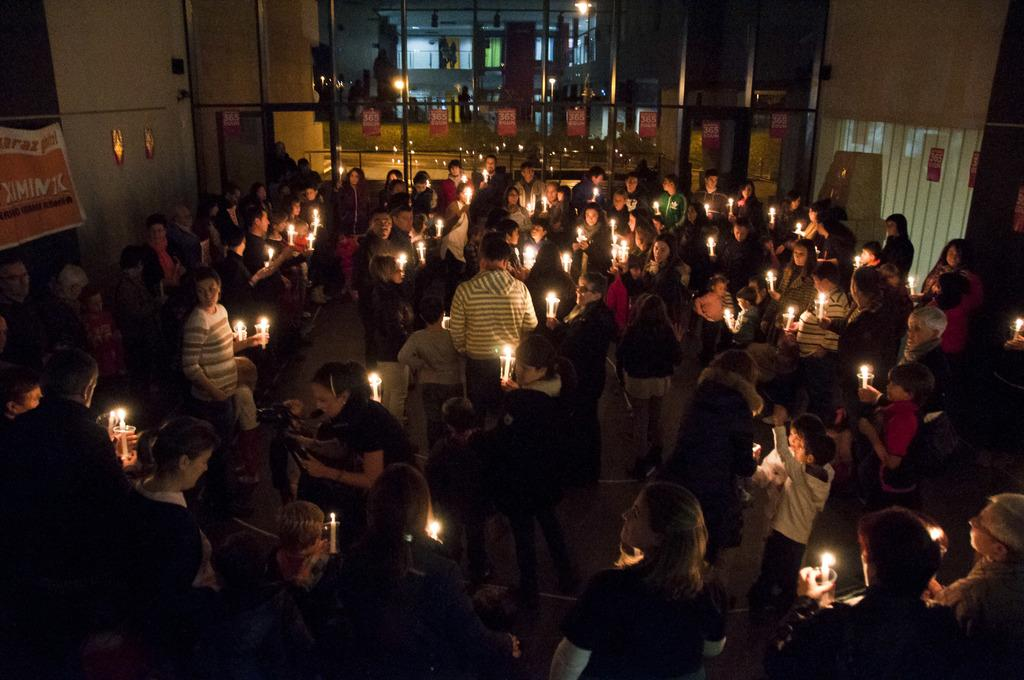Who or what is present in the image? There are people in the image. Where are the people located? The people are standing in a building. What are the people holding in their hands? The people are holding candles in their hands. What is the distance between the news and the base in the image? There is no news or base present in the image; it features people holding candles in a building. 